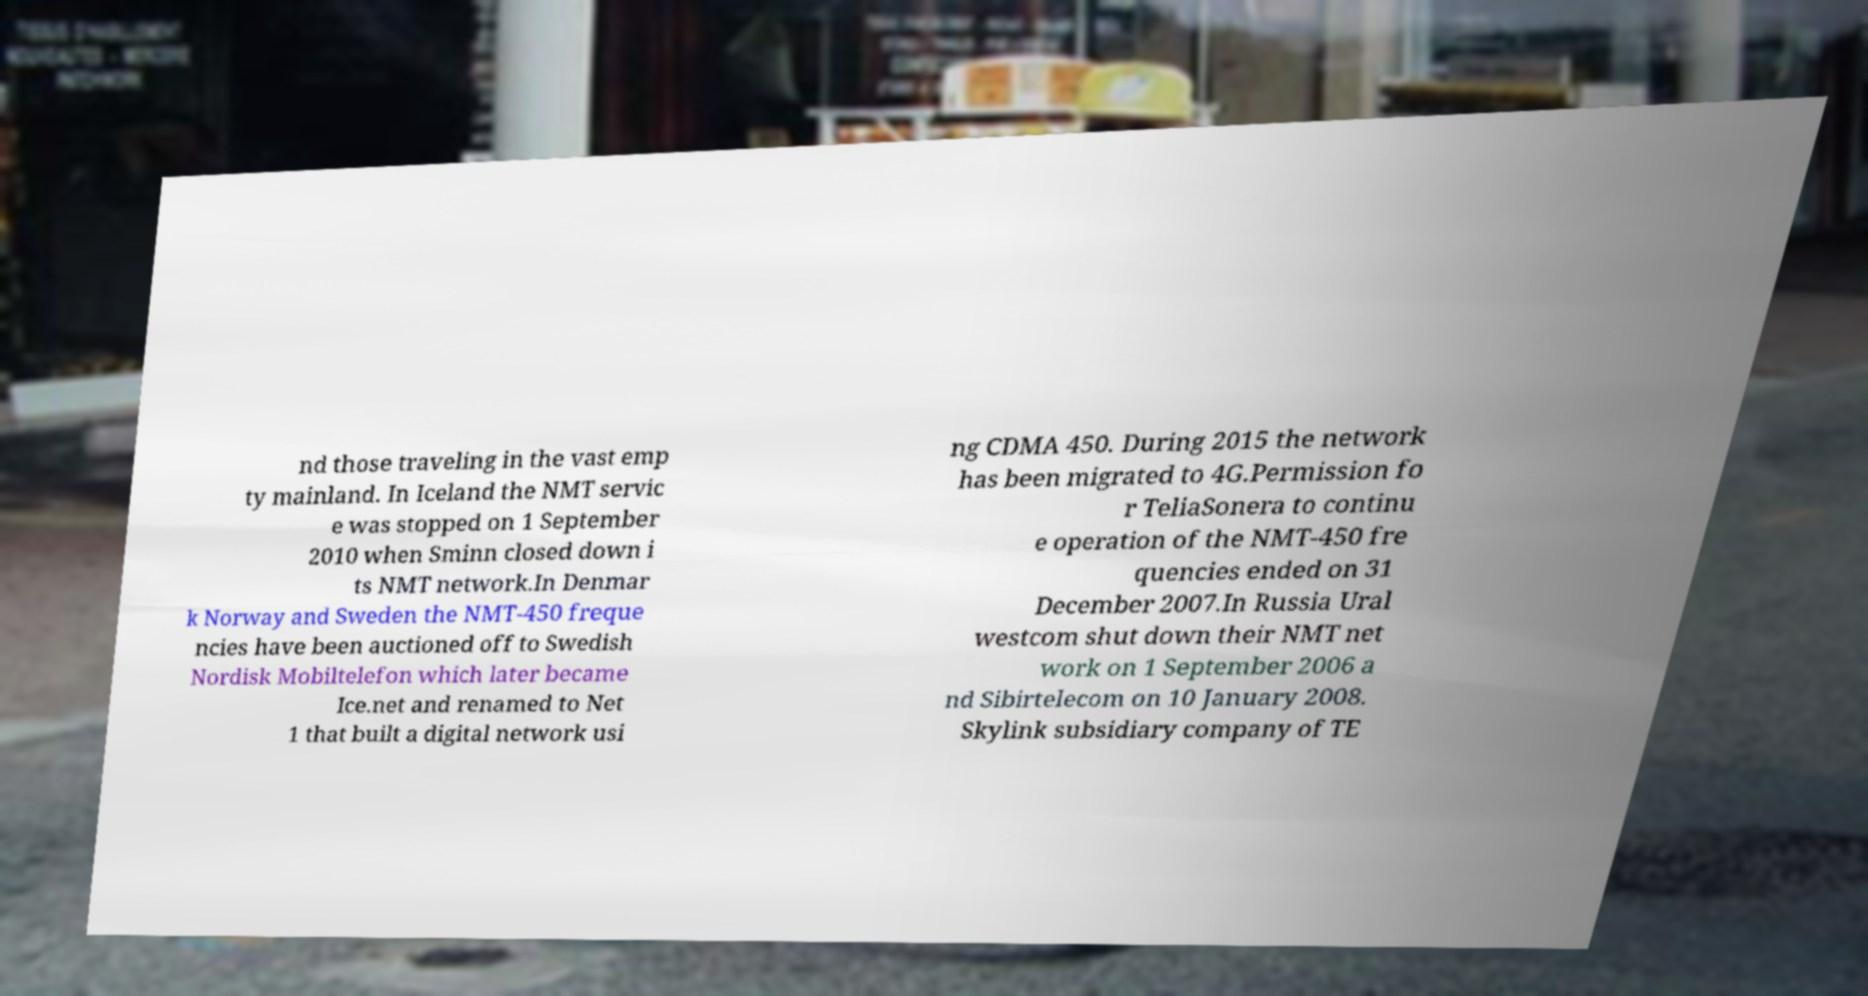What messages or text are displayed in this image? I need them in a readable, typed format. nd those traveling in the vast emp ty mainland. In Iceland the NMT servic e was stopped on 1 September 2010 when Sminn closed down i ts NMT network.In Denmar k Norway and Sweden the NMT-450 freque ncies have been auctioned off to Swedish Nordisk Mobiltelefon which later became Ice.net and renamed to Net 1 that built a digital network usi ng CDMA 450. During 2015 the network has been migrated to 4G.Permission fo r TeliaSonera to continu e operation of the NMT-450 fre quencies ended on 31 December 2007.In Russia Ural westcom shut down their NMT net work on 1 September 2006 a nd Sibirtelecom on 10 January 2008. Skylink subsidiary company of TE 